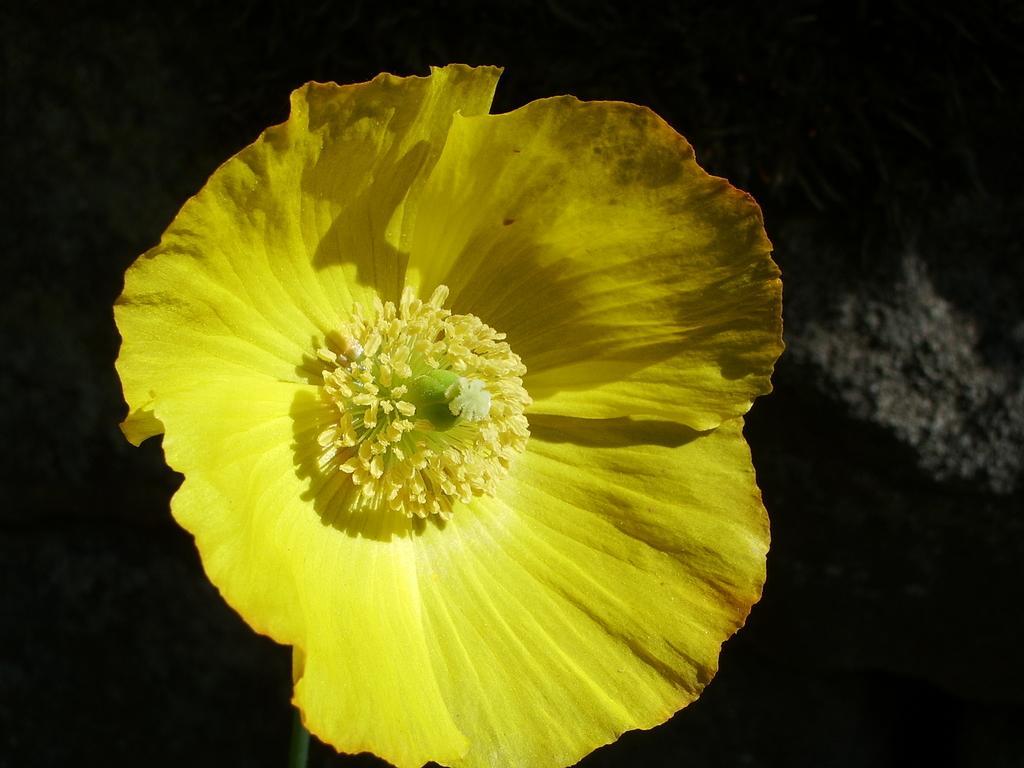How would you summarize this image in a sentence or two? In this image in the foreground there is one flower which is yellow in color, and in the background there is a wall. 